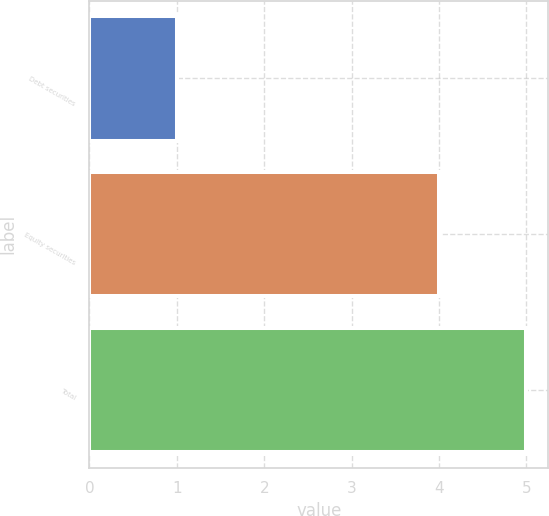Convert chart. <chart><loc_0><loc_0><loc_500><loc_500><bar_chart><fcel>Debt securities<fcel>Equity securities<fcel>Total<nl><fcel>1<fcel>4<fcel>5<nl></chart> 